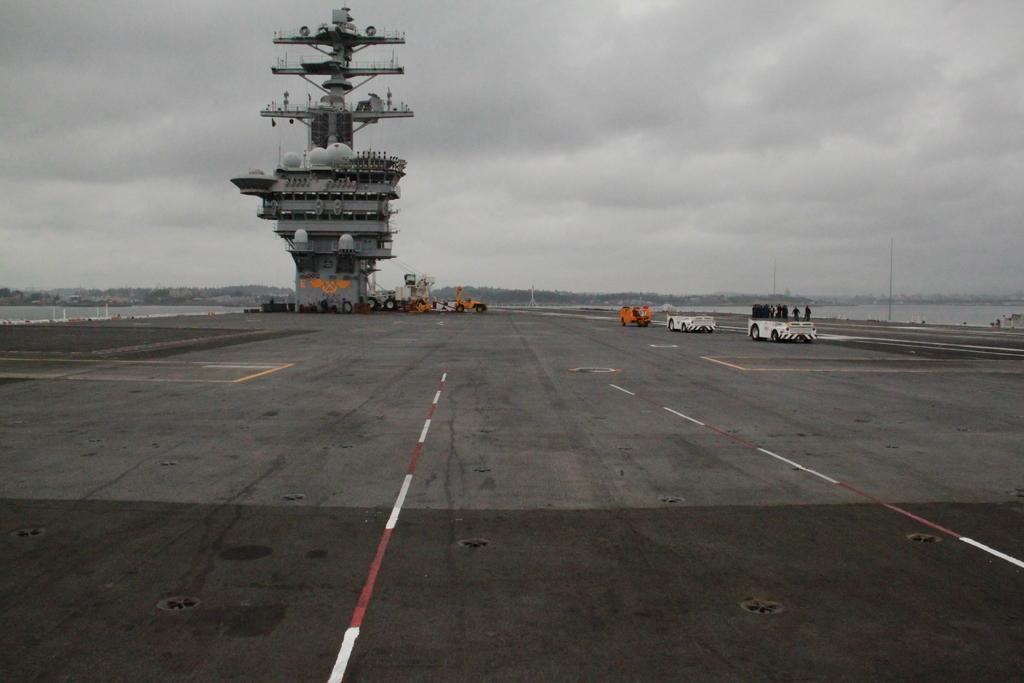Describe this image in one or two sentences. In the image we can see there are vehicles on the road. There are even people wearing clothes, here we can see a boat, poles and a cloudy sky. 